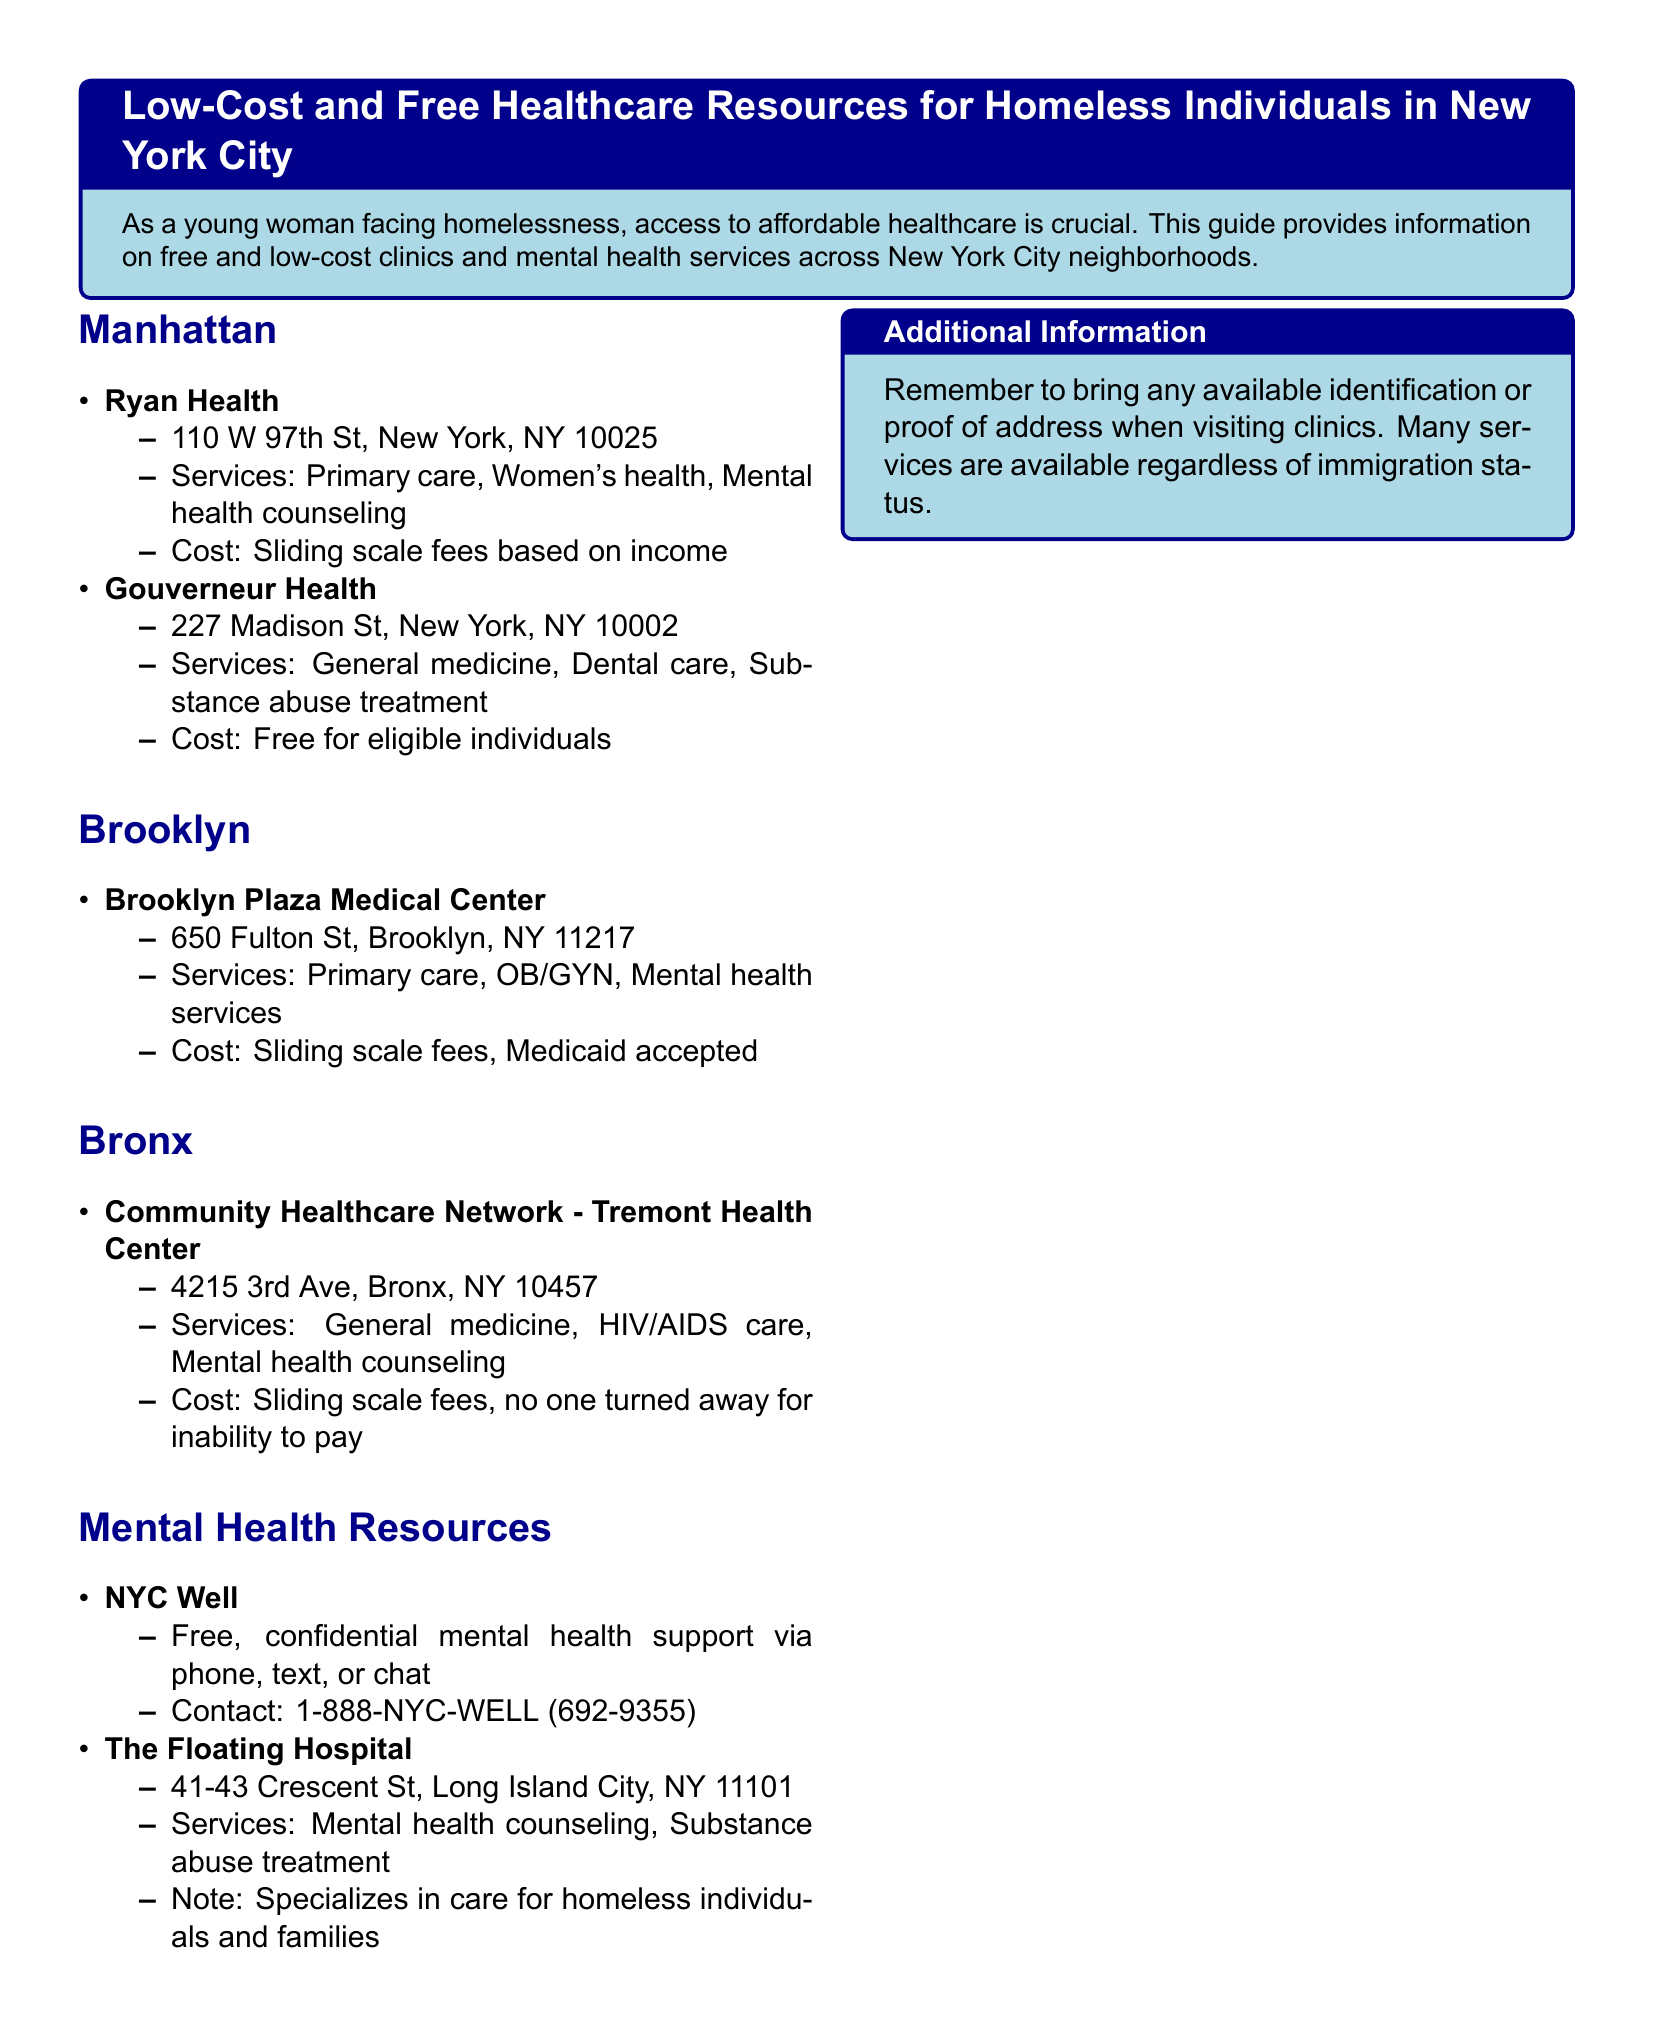what is the address of Ryan Health? The address is listed under Ryan Health in the Manhattan section of the document.
Answer: 110 W 97th St, New York, NY 10025 what services does Gouverneur Health offer? The services offered are mentioned in the description of Gouverneur Health in Manhattan.
Answer: General medicine, Dental care, Substance abuse treatment which neighborhood has Brooklyn Plaza Medical Center? The neighborhood is specified in the header before the listing of Brooklyn Plaza Medical Center.
Answer: Brooklyn what type of support does NYC Well provide? The type of support is noted in the description of NYC Well in the Mental Health Resources section.
Answer: Free, confidential mental health support how does Community Healthcare Network determine fees? The fee structure is indicated in the description of Community Healthcare Network.
Answer: Sliding scale fees, no one turned away for inability to pay what is the contact number for NYC Well? The contact number is provided in the description for NYC Well under Mental Health Resources.
Answer: 1-888-NYC-WELL (692-9355) what is the specialization of The Floating Hospital? The specialization is mentioned in the description of The Floating Hospital in the Mental Health Resources section.
Answer: Care for homeless individuals and families which clinic is located at 4215 3rd Ave, Bronx? The location is noted in the Community Healthcare Network - Tremont Health Center entry in the Bronx section.
Answer: Community Healthcare Network - Tremont Health Center what is the cost structure at Brooklyn Plaza Medical Center? The cost structure is specified in the information for Brooklyn Plaza Medical Center.
Answer: Sliding scale fees, Medicaid accepted 